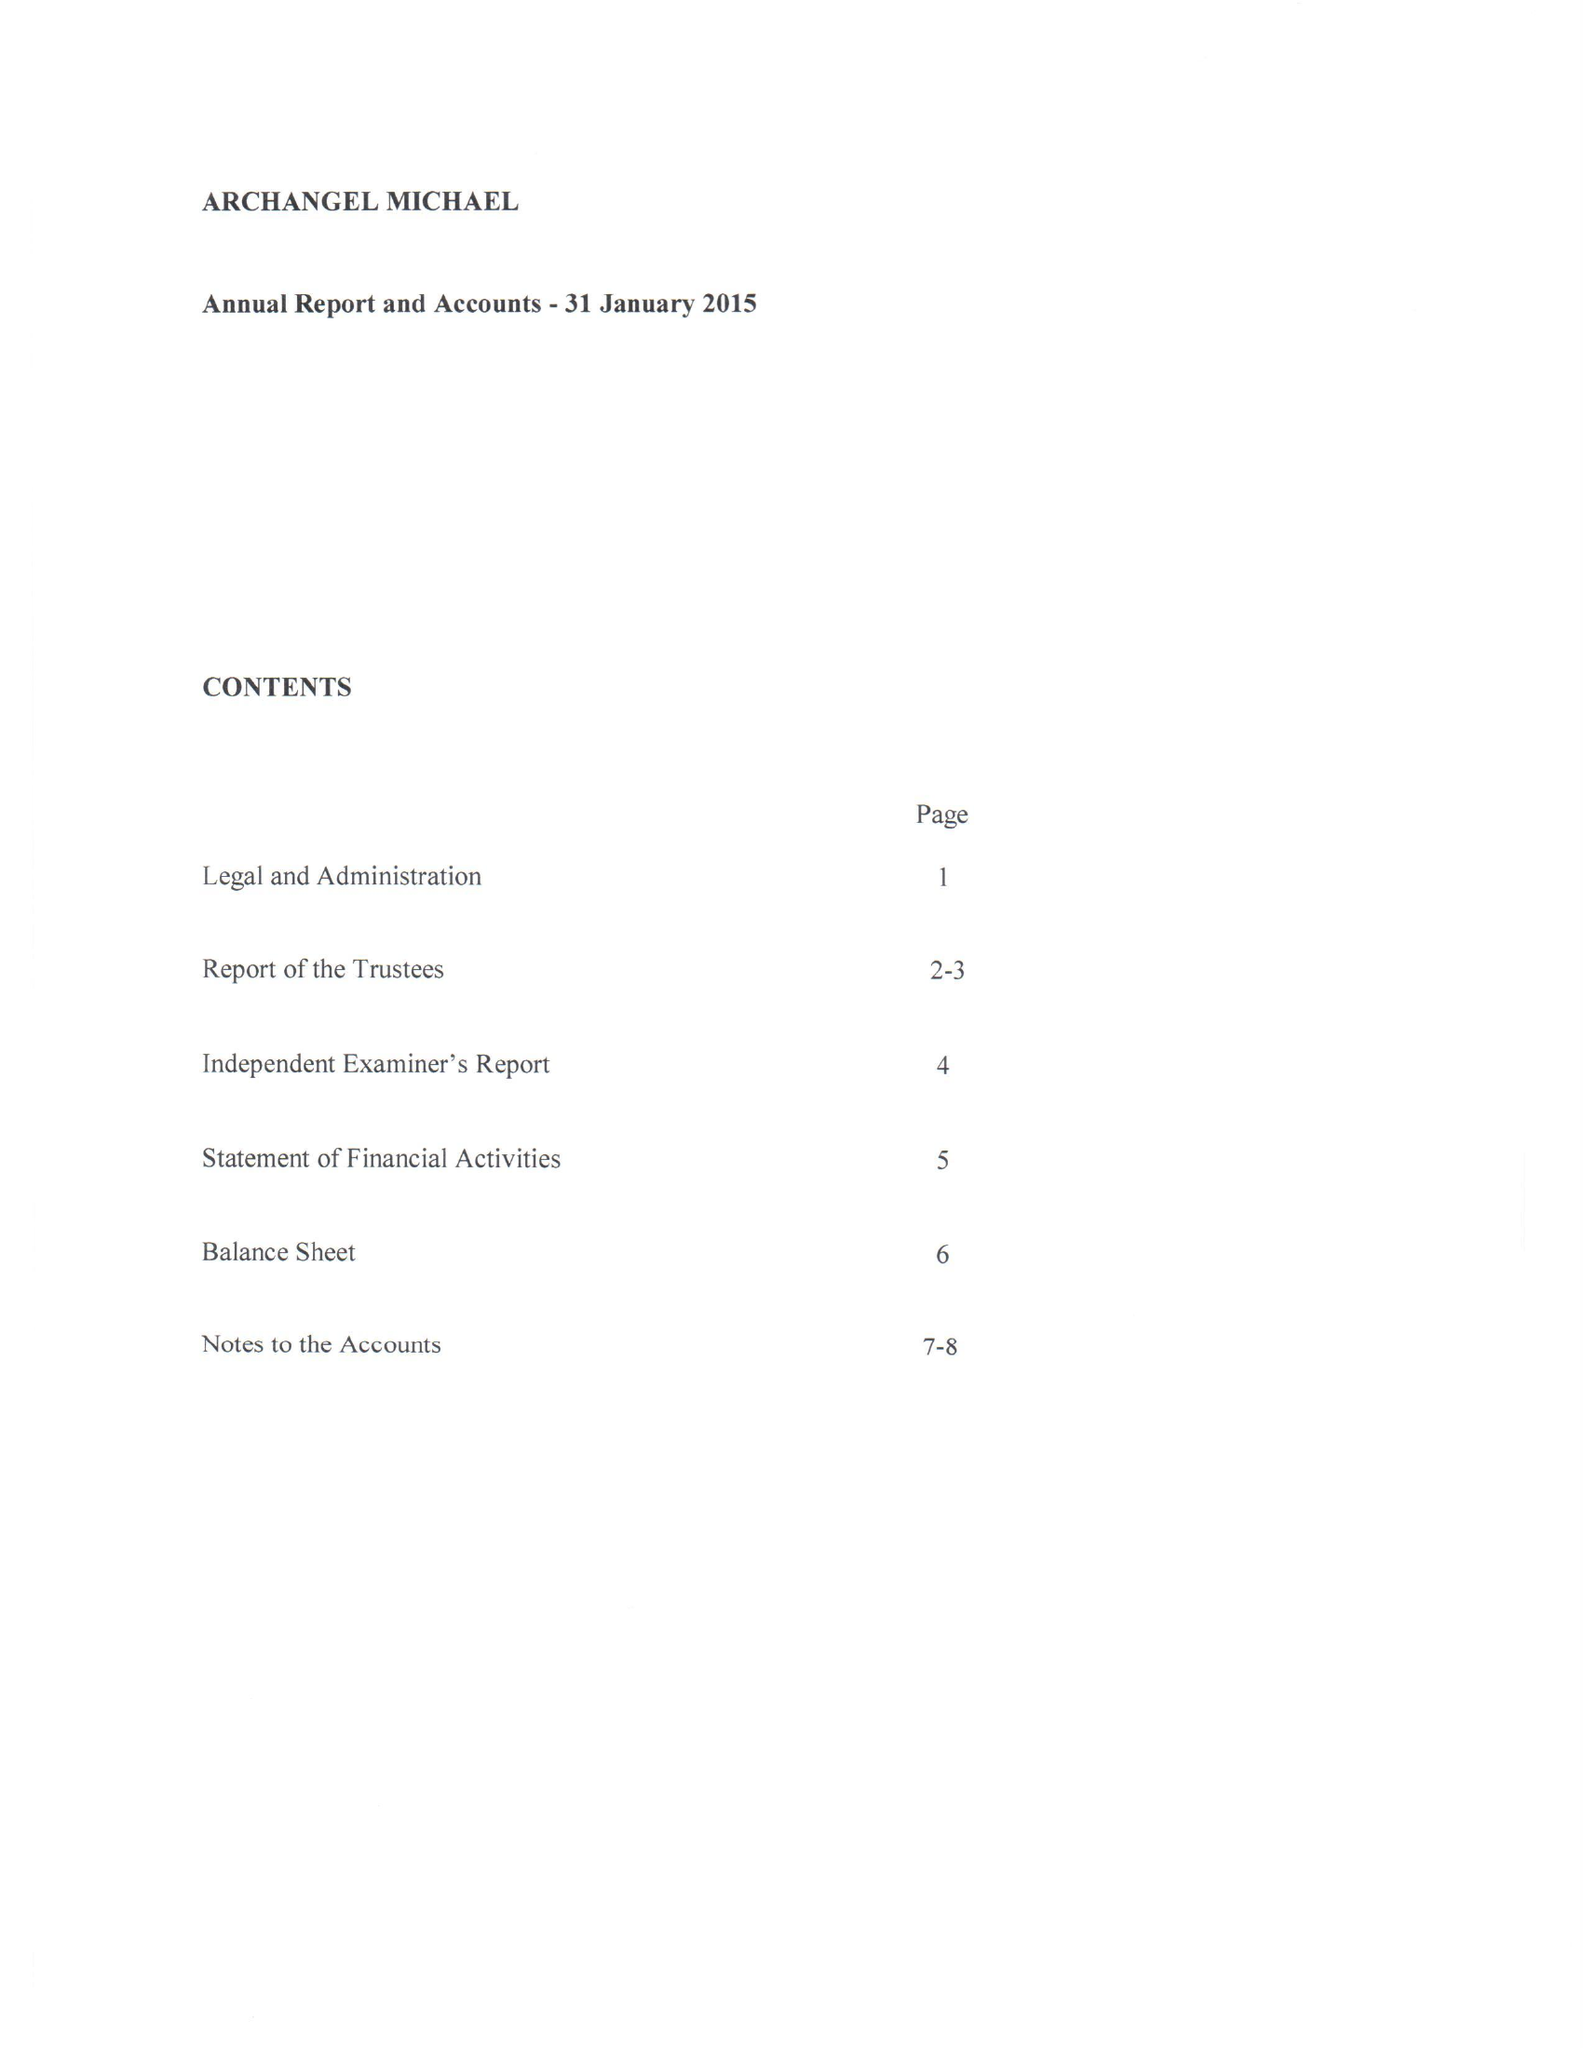What is the value for the charity_name?
Answer the question using a single word or phrase. Archangel Michael 